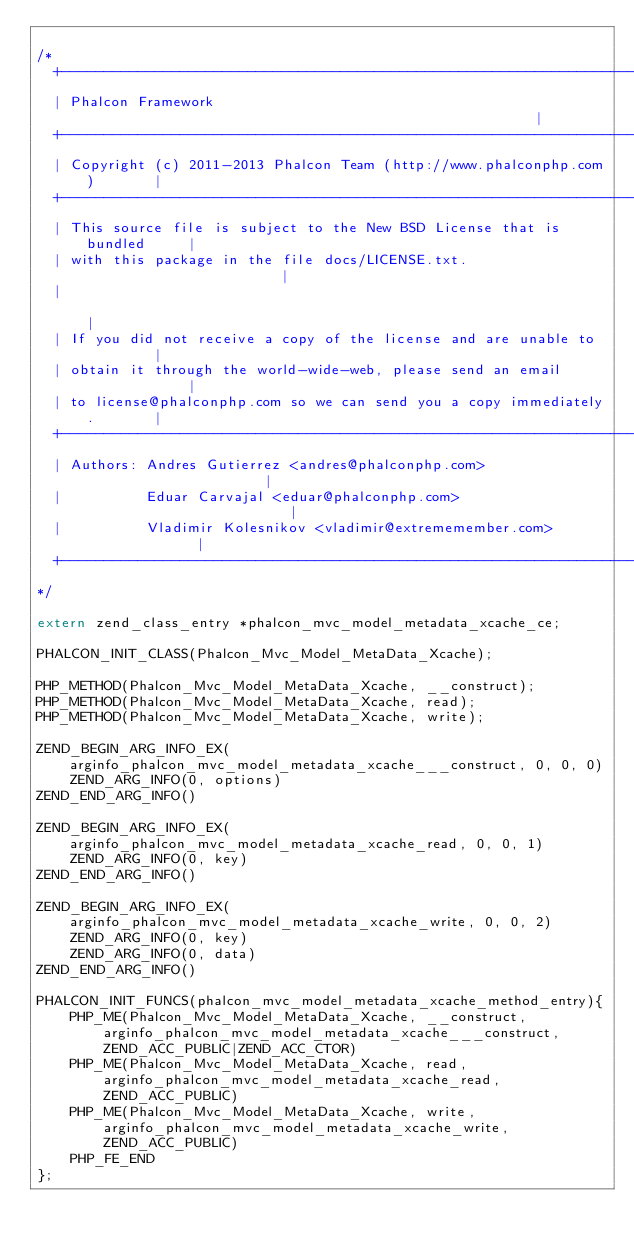<code> <loc_0><loc_0><loc_500><loc_500><_C_>
/*
  +------------------------------------------------------------------------+
  | Phalcon Framework                                                      |
  +------------------------------------------------------------------------+
  | Copyright (c) 2011-2013 Phalcon Team (http://www.phalconphp.com)       |
  +------------------------------------------------------------------------+
  | This source file is subject to the New BSD License that is bundled     |
  | with this package in the file docs/LICENSE.txt.                        |
  |                                                                        |
  | If you did not receive a copy of the license and are unable to         |
  | obtain it through the world-wide-web, please send an email             |
  | to license@phalconphp.com so we can send you a copy immediately.       |
  +------------------------------------------------------------------------+
  | Authors: Andres Gutierrez <andres@phalconphp.com>                      |
  |          Eduar Carvajal <eduar@phalconphp.com>                         |
  |          Vladimir Kolesnikov <vladimir@extrememember.com>              |
  +------------------------------------------------------------------------+
*/

extern zend_class_entry *phalcon_mvc_model_metadata_xcache_ce;

PHALCON_INIT_CLASS(Phalcon_Mvc_Model_MetaData_Xcache);

PHP_METHOD(Phalcon_Mvc_Model_MetaData_Xcache, __construct);
PHP_METHOD(Phalcon_Mvc_Model_MetaData_Xcache, read);
PHP_METHOD(Phalcon_Mvc_Model_MetaData_Xcache, write);

ZEND_BEGIN_ARG_INFO_EX(arginfo_phalcon_mvc_model_metadata_xcache___construct, 0, 0, 0)
	ZEND_ARG_INFO(0, options)
ZEND_END_ARG_INFO()

ZEND_BEGIN_ARG_INFO_EX(arginfo_phalcon_mvc_model_metadata_xcache_read, 0, 0, 1)
	ZEND_ARG_INFO(0, key)
ZEND_END_ARG_INFO()

ZEND_BEGIN_ARG_INFO_EX(arginfo_phalcon_mvc_model_metadata_xcache_write, 0, 0, 2)
	ZEND_ARG_INFO(0, key)
	ZEND_ARG_INFO(0, data)
ZEND_END_ARG_INFO()

PHALCON_INIT_FUNCS(phalcon_mvc_model_metadata_xcache_method_entry){
	PHP_ME(Phalcon_Mvc_Model_MetaData_Xcache, __construct, arginfo_phalcon_mvc_model_metadata_xcache___construct, ZEND_ACC_PUBLIC|ZEND_ACC_CTOR) 
	PHP_ME(Phalcon_Mvc_Model_MetaData_Xcache, read, arginfo_phalcon_mvc_model_metadata_xcache_read, ZEND_ACC_PUBLIC) 
	PHP_ME(Phalcon_Mvc_Model_MetaData_Xcache, write, arginfo_phalcon_mvc_model_metadata_xcache_write, ZEND_ACC_PUBLIC) 
	PHP_FE_END
};

</code> 